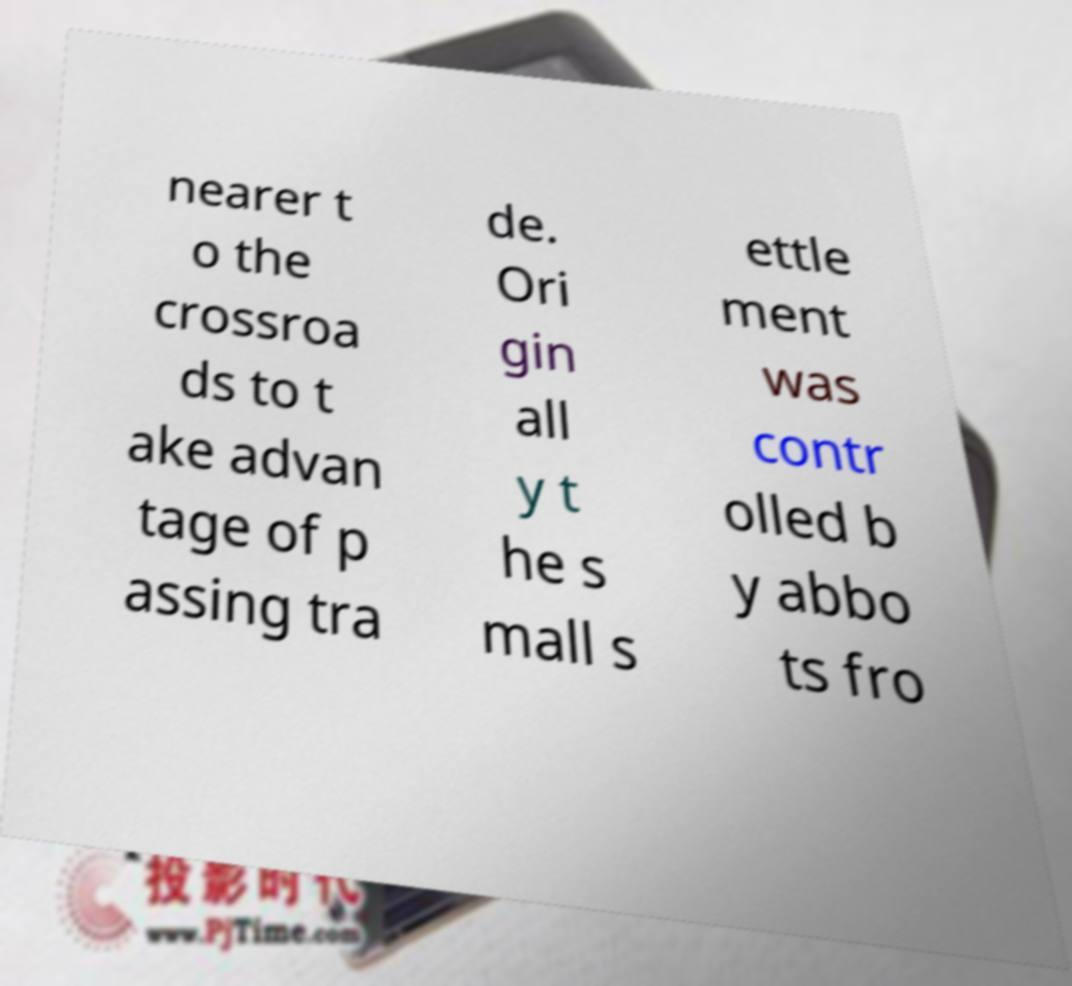What messages or text are displayed in this image? I need them in a readable, typed format. nearer t o the crossroa ds to t ake advan tage of p assing tra de. Ori gin all y t he s mall s ettle ment was contr olled b y abbo ts fro 